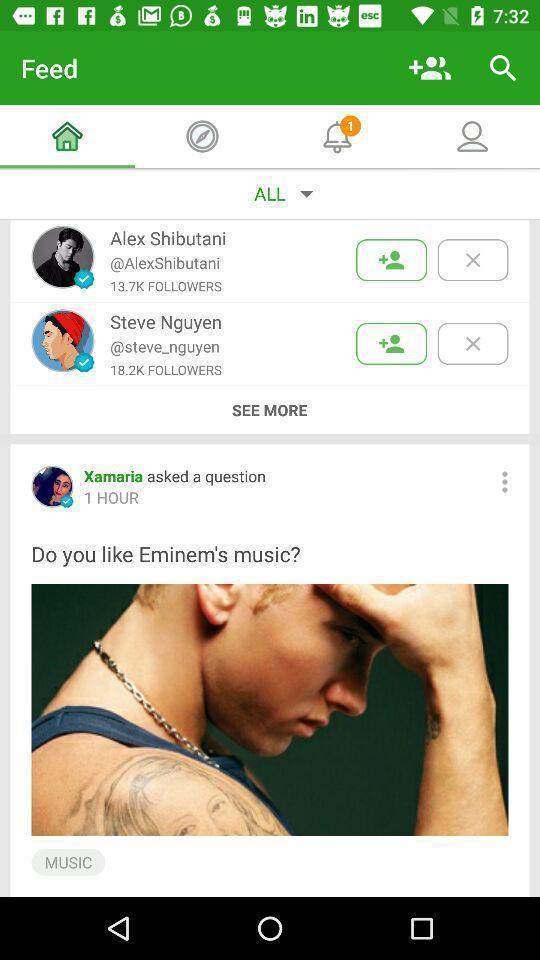Describe the visual elements of this screenshot. Screen page showing different options. 